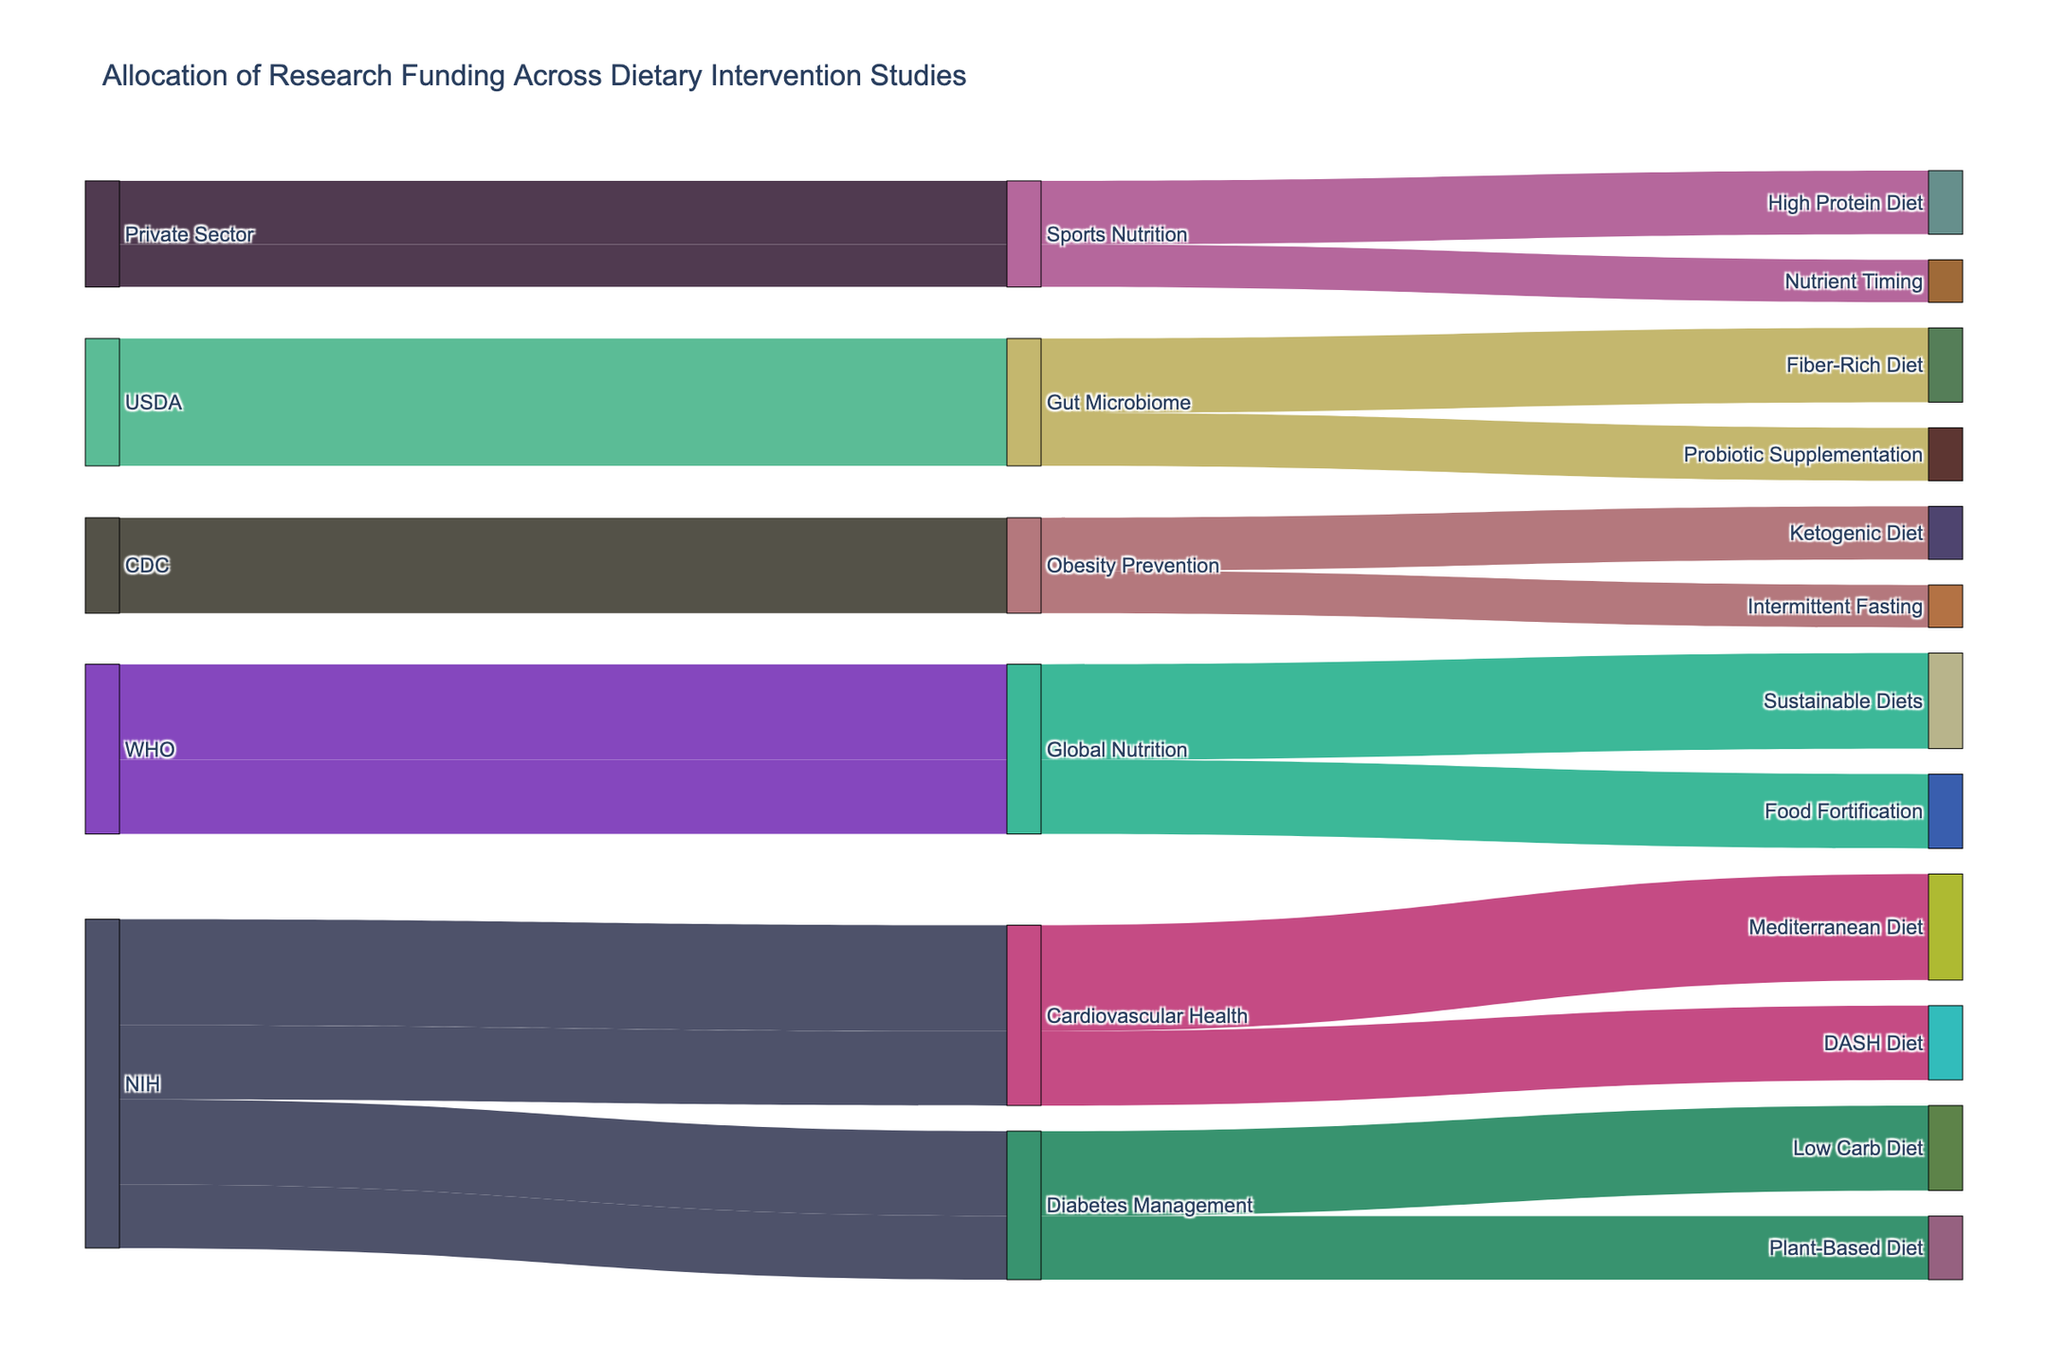What's the title of the figure? The title is usually the text displayed at the top of the figure, summarizing the content or purpose of the visualization. In this case, it's written in a larger font size.
Answer: Allocation of Research Funding Across Dietary Intervention Studies Which source has allocated the most funding to cardiovascular health interventions? To find this, look at the node labeled "Cardiovascular Health" and see which node labeled "Source" has the larger connecting flow. Two such connections exist: NIH funding Mediterranean Diet and DASH Diet. NIH's allocation is listed as $5,000,000 for Mediterranean Diet and $3,500,000 for DASH Diet, totalling $8,500,000.
Answer: NIH How much total funding has the USDA allocated to gut microbiome studies? Sum the values assigned from USDA to intermediate nodes related to Gut Microbiome: Fiber-Rich Diet receives $3,500,000 and Probiotic Supplementation receives $2,500,000. The sum is $3,500,000 + $2,500,000.
Answer: $6,000,000 Which dietary intervention received the largest amount from the WHO? To answer, examine the flows originating from WHO to specific targets and compare their values. The WHO provides $4,500,000 for Sustainable Diets and $3,500,000 for Food Fortification.
Answer: Sustainable Diets Compare the total funding for Diabetes Management and Obesity Prevention studies. Which category received more funding? Sum the funds allocated to both Diabetes Management studies (Low Carb Diet $4,000,000 and Plant-Based Diet $3,000,000 for a total $7,000,000) and Obesity Prevention studies (Ketogenic Diet $2,500,000 and Intermittent Fasting $2,000,000 for a total $4,500,000). Diabetes Management received more funding.
Answer: Diabetes Management What amount of funding has the private sector allocated in total for sports nutrition? Add the values allocated to each sports nutrition intervention: High Protein Diet receives $3,000,000 and Nutrient Timing receives $2,000,000.
Answer: $5,000,000 Compare the funding amounts for the Ketogenic Diet and Low Carb Diet. Which study has more funding? Locate the flows for Ketogenic Diet ($2,500,000) and Low Carb Diet ($4,000,000) and determine which value is higher.
Answer: Low Carb Diet Is there any dietary intervention study funded by more than one source? Examine all connecting flows to check if any target node (dietary intervention) is connected to more than one source node. In this figure, no dietary intervention study is funded by more than one source.
Answer: No What's the average funding amount allocated by the CDC? Compute the average by summing the amounts of each CDC-funded intervention (Ketogenic Diet $2,500,000 and Intermittent Fasting $2,000,000), which totals $4,500,000, then divide by the number of interventions.
Answer: $2,250,000 Which intermediate category received the most funding and how much? Check each intermediate category (Cardiovascular Health, Diabetes Management, Obesity Prevention, Gut Microbiome, Global Nutrition, and Sports Nutrition) by summing their incoming flows and compare these sums. Cardiovascular Health received the most: Mediterranean Diet $5,000,000 and DASH Diet $3,500,000, totaling $8,500,000.
Answer: Cardiovascular Health; $8,500,000 